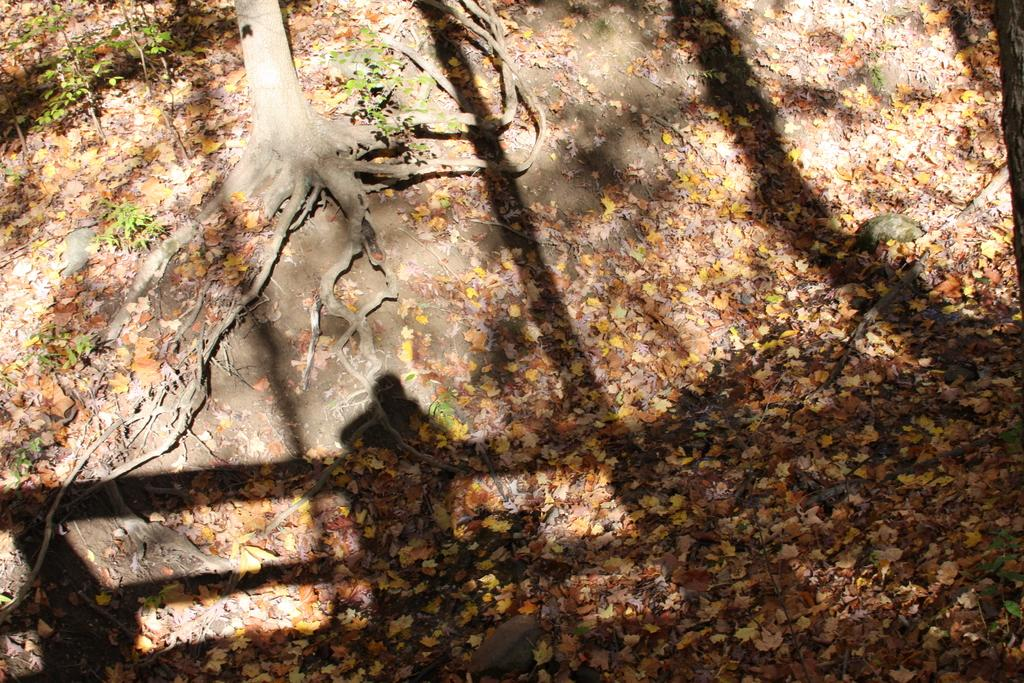What is the main subject of the image? The main subject of the image is tree bark. Can you describe any specific features of the tree bark? Yes, the tree bark has visible roots. What else can be seen on the ground in the image? There are leaves on the ground in the image. What type of egg is visible in the image? There is no egg present in the image; it features tree bark with visible roots and leaves on the ground. What is the texture of the neck in the image? There is no neck present in the image; it only contains tree bark with visible roots and leaves on the ground. 